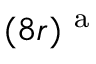Convert formula to latex. <formula><loc_0><loc_0><loc_500><loc_500>( 8 r ) ^ { a }</formula> 